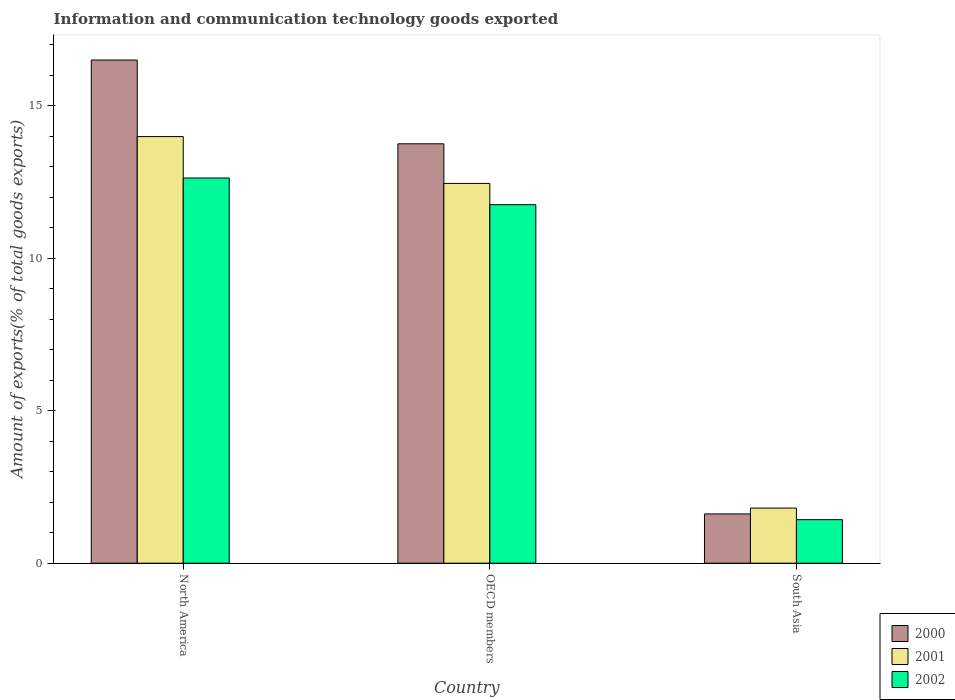How many bars are there on the 1st tick from the right?
Make the answer very short. 3. What is the amount of goods exported in 2002 in North America?
Offer a terse response. 12.63. Across all countries, what is the maximum amount of goods exported in 2000?
Provide a succinct answer. 16.5. Across all countries, what is the minimum amount of goods exported in 2001?
Provide a succinct answer. 1.81. In which country was the amount of goods exported in 2001 maximum?
Provide a short and direct response. North America. What is the total amount of goods exported in 2001 in the graph?
Provide a short and direct response. 28.25. What is the difference between the amount of goods exported in 2002 in North America and that in South Asia?
Your answer should be compact. 11.21. What is the difference between the amount of goods exported in 2001 in OECD members and the amount of goods exported in 2002 in South Asia?
Keep it short and to the point. 11.03. What is the average amount of goods exported in 2002 per country?
Keep it short and to the point. 8.61. What is the difference between the amount of goods exported of/in 2001 and amount of goods exported of/in 2002 in South Asia?
Give a very brief answer. 0.38. What is the ratio of the amount of goods exported in 2001 in North America to that in South Asia?
Offer a very short reply. 7.74. Is the amount of goods exported in 2000 in OECD members less than that in South Asia?
Provide a succinct answer. No. Is the difference between the amount of goods exported in 2001 in North America and South Asia greater than the difference between the amount of goods exported in 2002 in North America and South Asia?
Keep it short and to the point. Yes. What is the difference between the highest and the second highest amount of goods exported in 2000?
Ensure brevity in your answer.  14.88. What is the difference between the highest and the lowest amount of goods exported in 2000?
Make the answer very short. 14.88. In how many countries, is the amount of goods exported in 2002 greater than the average amount of goods exported in 2002 taken over all countries?
Your answer should be very brief. 2. Is the sum of the amount of goods exported in 2002 in North America and South Asia greater than the maximum amount of goods exported in 2000 across all countries?
Your answer should be compact. No. What does the 1st bar from the right in OECD members represents?
Keep it short and to the point. 2002. Is it the case that in every country, the sum of the amount of goods exported in 2001 and amount of goods exported in 2000 is greater than the amount of goods exported in 2002?
Your answer should be compact. Yes. Does the graph contain grids?
Offer a very short reply. No. Where does the legend appear in the graph?
Offer a terse response. Bottom right. What is the title of the graph?
Your response must be concise. Information and communication technology goods exported. What is the label or title of the X-axis?
Make the answer very short. Country. What is the label or title of the Y-axis?
Ensure brevity in your answer.  Amount of exports(% of total goods exports). What is the Amount of exports(% of total goods exports) in 2000 in North America?
Offer a very short reply. 16.5. What is the Amount of exports(% of total goods exports) in 2001 in North America?
Your answer should be very brief. 13.99. What is the Amount of exports(% of total goods exports) of 2002 in North America?
Make the answer very short. 12.63. What is the Amount of exports(% of total goods exports) in 2000 in OECD members?
Ensure brevity in your answer.  13.75. What is the Amount of exports(% of total goods exports) of 2001 in OECD members?
Give a very brief answer. 12.45. What is the Amount of exports(% of total goods exports) of 2002 in OECD members?
Provide a succinct answer. 11.76. What is the Amount of exports(% of total goods exports) of 2000 in South Asia?
Make the answer very short. 1.62. What is the Amount of exports(% of total goods exports) of 2001 in South Asia?
Make the answer very short. 1.81. What is the Amount of exports(% of total goods exports) in 2002 in South Asia?
Your response must be concise. 1.43. Across all countries, what is the maximum Amount of exports(% of total goods exports) of 2000?
Your answer should be very brief. 16.5. Across all countries, what is the maximum Amount of exports(% of total goods exports) in 2001?
Provide a short and direct response. 13.99. Across all countries, what is the maximum Amount of exports(% of total goods exports) in 2002?
Offer a terse response. 12.63. Across all countries, what is the minimum Amount of exports(% of total goods exports) in 2000?
Your answer should be very brief. 1.62. Across all countries, what is the minimum Amount of exports(% of total goods exports) of 2001?
Give a very brief answer. 1.81. Across all countries, what is the minimum Amount of exports(% of total goods exports) of 2002?
Provide a succinct answer. 1.43. What is the total Amount of exports(% of total goods exports) of 2000 in the graph?
Offer a terse response. 31.87. What is the total Amount of exports(% of total goods exports) in 2001 in the graph?
Your response must be concise. 28.25. What is the total Amount of exports(% of total goods exports) in 2002 in the graph?
Provide a short and direct response. 25.82. What is the difference between the Amount of exports(% of total goods exports) in 2000 in North America and that in OECD members?
Offer a terse response. 2.75. What is the difference between the Amount of exports(% of total goods exports) of 2001 in North America and that in OECD members?
Your response must be concise. 1.54. What is the difference between the Amount of exports(% of total goods exports) in 2002 in North America and that in OECD members?
Offer a very short reply. 0.88. What is the difference between the Amount of exports(% of total goods exports) in 2000 in North America and that in South Asia?
Give a very brief answer. 14.88. What is the difference between the Amount of exports(% of total goods exports) in 2001 in North America and that in South Asia?
Make the answer very short. 12.18. What is the difference between the Amount of exports(% of total goods exports) of 2002 in North America and that in South Asia?
Give a very brief answer. 11.21. What is the difference between the Amount of exports(% of total goods exports) in 2000 in OECD members and that in South Asia?
Make the answer very short. 12.14. What is the difference between the Amount of exports(% of total goods exports) in 2001 in OECD members and that in South Asia?
Offer a terse response. 10.65. What is the difference between the Amount of exports(% of total goods exports) of 2002 in OECD members and that in South Asia?
Your answer should be very brief. 10.33. What is the difference between the Amount of exports(% of total goods exports) of 2000 in North America and the Amount of exports(% of total goods exports) of 2001 in OECD members?
Your answer should be very brief. 4.05. What is the difference between the Amount of exports(% of total goods exports) of 2000 in North America and the Amount of exports(% of total goods exports) of 2002 in OECD members?
Keep it short and to the point. 4.74. What is the difference between the Amount of exports(% of total goods exports) in 2001 in North America and the Amount of exports(% of total goods exports) in 2002 in OECD members?
Offer a terse response. 2.23. What is the difference between the Amount of exports(% of total goods exports) of 2000 in North America and the Amount of exports(% of total goods exports) of 2001 in South Asia?
Keep it short and to the point. 14.69. What is the difference between the Amount of exports(% of total goods exports) in 2000 in North America and the Amount of exports(% of total goods exports) in 2002 in South Asia?
Offer a very short reply. 15.07. What is the difference between the Amount of exports(% of total goods exports) in 2001 in North America and the Amount of exports(% of total goods exports) in 2002 in South Asia?
Ensure brevity in your answer.  12.56. What is the difference between the Amount of exports(% of total goods exports) of 2000 in OECD members and the Amount of exports(% of total goods exports) of 2001 in South Asia?
Make the answer very short. 11.95. What is the difference between the Amount of exports(% of total goods exports) of 2000 in OECD members and the Amount of exports(% of total goods exports) of 2002 in South Asia?
Provide a succinct answer. 12.33. What is the difference between the Amount of exports(% of total goods exports) in 2001 in OECD members and the Amount of exports(% of total goods exports) in 2002 in South Asia?
Your answer should be compact. 11.03. What is the average Amount of exports(% of total goods exports) in 2000 per country?
Offer a very short reply. 10.62. What is the average Amount of exports(% of total goods exports) of 2001 per country?
Your response must be concise. 9.42. What is the average Amount of exports(% of total goods exports) in 2002 per country?
Your answer should be compact. 8.61. What is the difference between the Amount of exports(% of total goods exports) of 2000 and Amount of exports(% of total goods exports) of 2001 in North America?
Offer a terse response. 2.51. What is the difference between the Amount of exports(% of total goods exports) in 2000 and Amount of exports(% of total goods exports) in 2002 in North America?
Offer a terse response. 3.87. What is the difference between the Amount of exports(% of total goods exports) in 2001 and Amount of exports(% of total goods exports) in 2002 in North America?
Give a very brief answer. 1.36. What is the difference between the Amount of exports(% of total goods exports) of 2000 and Amount of exports(% of total goods exports) of 2001 in OECD members?
Provide a short and direct response. 1.3. What is the difference between the Amount of exports(% of total goods exports) in 2000 and Amount of exports(% of total goods exports) in 2002 in OECD members?
Your response must be concise. 2. What is the difference between the Amount of exports(% of total goods exports) of 2001 and Amount of exports(% of total goods exports) of 2002 in OECD members?
Offer a very short reply. 0.7. What is the difference between the Amount of exports(% of total goods exports) of 2000 and Amount of exports(% of total goods exports) of 2001 in South Asia?
Make the answer very short. -0.19. What is the difference between the Amount of exports(% of total goods exports) of 2000 and Amount of exports(% of total goods exports) of 2002 in South Asia?
Your response must be concise. 0.19. What is the difference between the Amount of exports(% of total goods exports) of 2001 and Amount of exports(% of total goods exports) of 2002 in South Asia?
Make the answer very short. 0.38. What is the ratio of the Amount of exports(% of total goods exports) in 2000 in North America to that in OECD members?
Your answer should be compact. 1.2. What is the ratio of the Amount of exports(% of total goods exports) in 2001 in North America to that in OECD members?
Give a very brief answer. 1.12. What is the ratio of the Amount of exports(% of total goods exports) in 2002 in North America to that in OECD members?
Offer a very short reply. 1.07. What is the ratio of the Amount of exports(% of total goods exports) of 2000 in North America to that in South Asia?
Your response must be concise. 10.21. What is the ratio of the Amount of exports(% of total goods exports) in 2001 in North America to that in South Asia?
Ensure brevity in your answer.  7.74. What is the ratio of the Amount of exports(% of total goods exports) in 2002 in North America to that in South Asia?
Offer a very short reply. 8.85. What is the ratio of the Amount of exports(% of total goods exports) in 2000 in OECD members to that in South Asia?
Provide a succinct answer. 8.51. What is the ratio of the Amount of exports(% of total goods exports) in 2001 in OECD members to that in South Asia?
Give a very brief answer. 6.89. What is the ratio of the Amount of exports(% of total goods exports) of 2002 in OECD members to that in South Asia?
Give a very brief answer. 8.23. What is the difference between the highest and the second highest Amount of exports(% of total goods exports) in 2000?
Make the answer very short. 2.75. What is the difference between the highest and the second highest Amount of exports(% of total goods exports) of 2001?
Provide a short and direct response. 1.54. What is the difference between the highest and the second highest Amount of exports(% of total goods exports) of 2002?
Your response must be concise. 0.88. What is the difference between the highest and the lowest Amount of exports(% of total goods exports) in 2000?
Give a very brief answer. 14.88. What is the difference between the highest and the lowest Amount of exports(% of total goods exports) in 2001?
Your response must be concise. 12.18. What is the difference between the highest and the lowest Amount of exports(% of total goods exports) of 2002?
Provide a succinct answer. 11.21. 